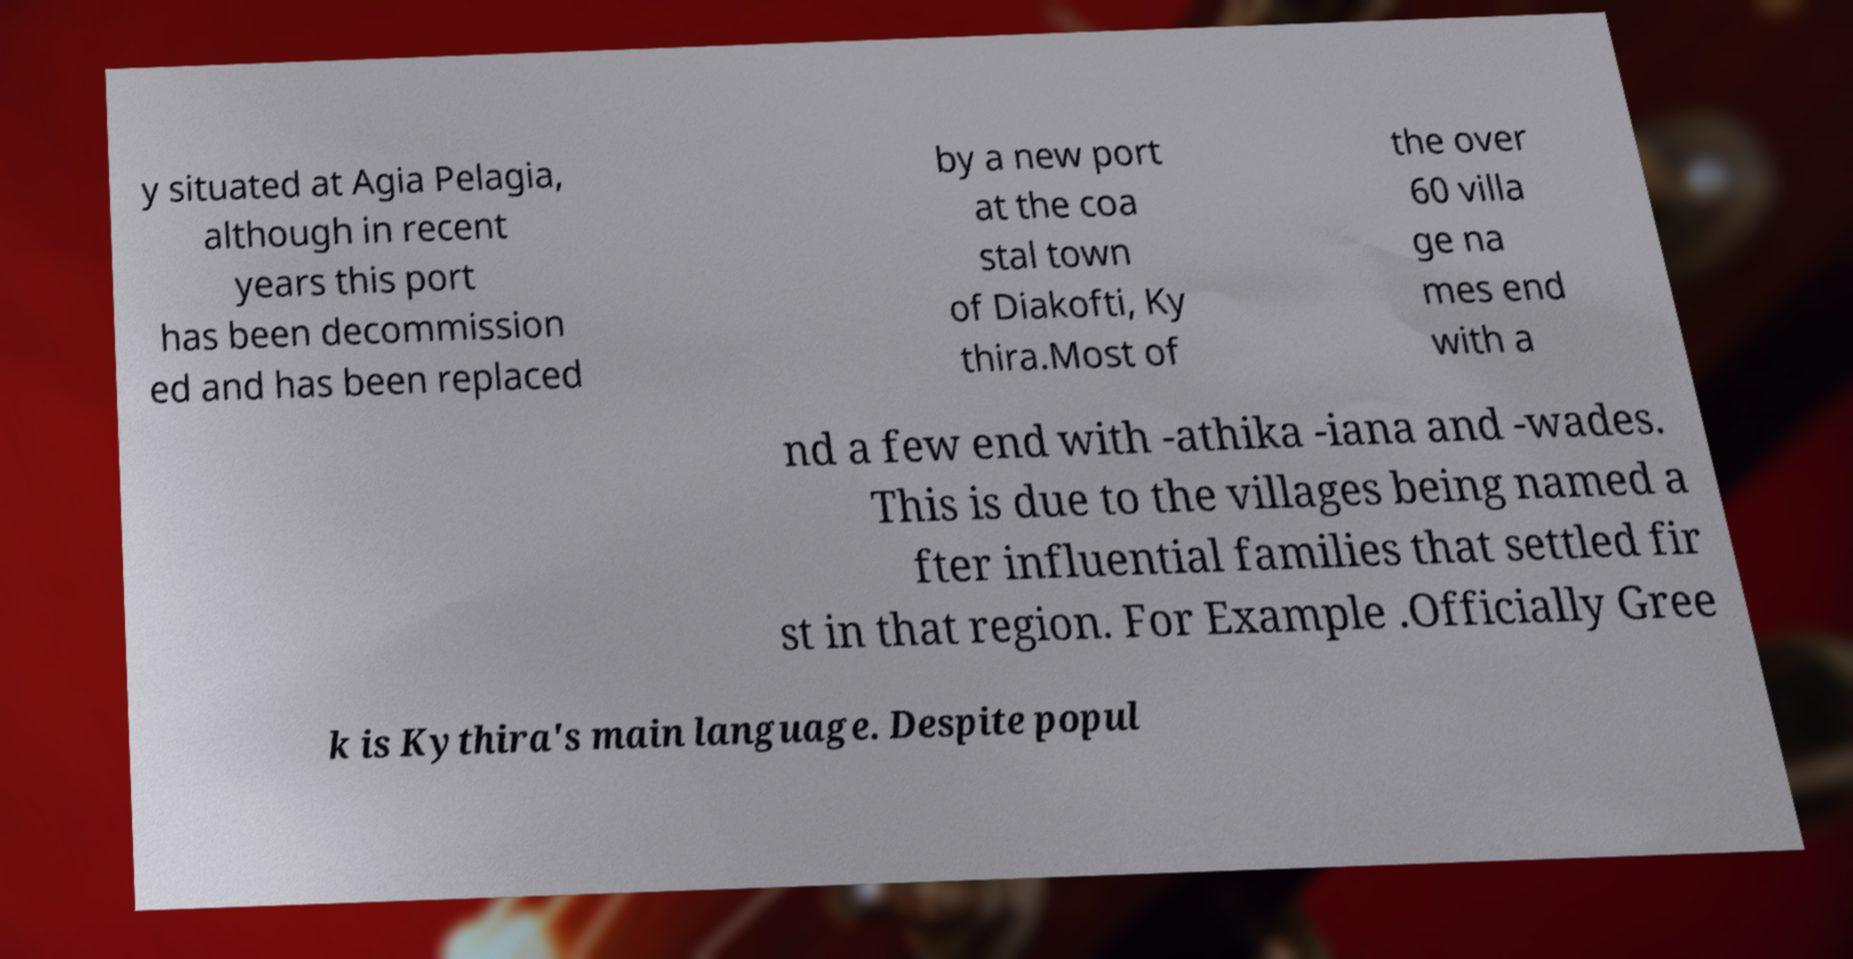For documentation purposes, I need the text within this image transcribed. Could you provide that? y situated at Agia Pelagia, although in recent years this port has been decommission ed and has been replaced by a new port at the coa stal town of Diakofti, Ky thira.Most of the over 60 villa ge na mes end with a nd a few end with -athika -iana and -wades. This is due to the villages being named a fter influential families that settled fir st in that region. For Example .Officially Gree k is Kythira's main language. Despite popul 